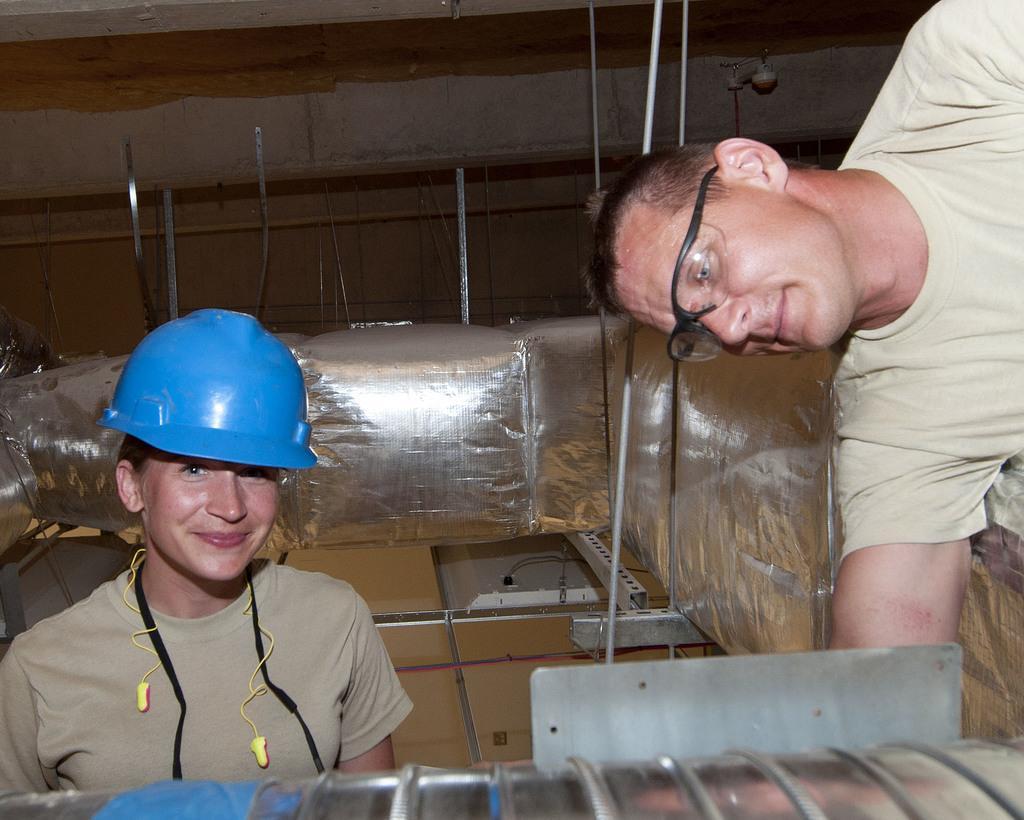Describe this image in one or two sentences. In this image we can see two persons wearing cream color T-shirt, one person wearing spectacles bending doing some work and a person wearing blue color cap and ear pods smiling, there are some AC vents in the background and foreground of the image. 